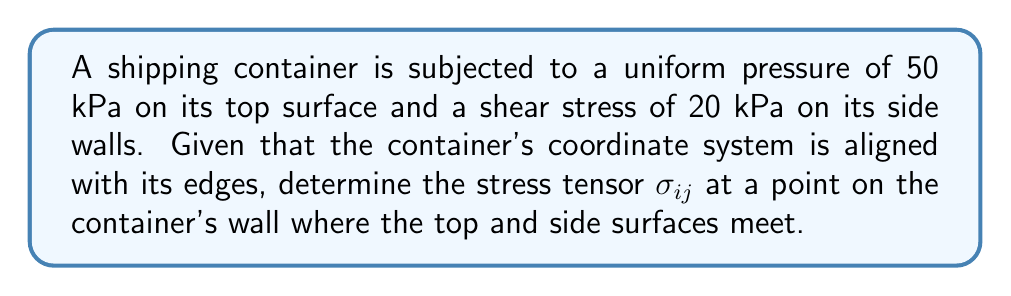Can you answer this question? To solve this problem, we'll follow these steps:

1) In tensor notation, the stress tensor $\sigma_{ij}$ is a 3x3 matrix representing the state of stress at a point. The components are:

   $$\sigma_{ij} = \begin{bmatrix} 
   \sigma_{xx} & \tau_{xy} & \tau_{xz} \\
   \tau_{yx} & \sigma_{yy} & \tau_{yz} \\
   \tau_{zx} & \tau_{zy} & \sigma_{zz}
   \end{bmatrix}$$

2) Given information:
   - Uniform pressure on top surface: 50 kPa
   - Shear stress on side walls: 20 kPa

3) Assume the coordinate system is as follows:
   - x-axis: along the length of the container
   - y-axis: along the width of the container
   - z-axis: along the height of the container

4) The uniform pressure on the top surface acts in the negative z-direction:
   $\sigma_{zz} = -50$ kPa

5) The shear stress on the side walls can be represented by $\tau_{xz}$ and $\tau_{yz}$:
   $\tau_{xz} = \tau_{zx} = 20$ kPa
   $\tau_{yz} = \tau_{zy} = 20$ kPa

6) All other components of the stress tensor are zero, as no other stresses are mentioned.

7) Therefore, the complete stress tensor is:

   $$\sigma_{ij} = \begin{bmatrix} 
   0 & 0 & 20 \\
   0 & 0 & 20 \\
   20 & 20 & -50
   \end{bmatrix}$$ kPa
Answer: $$\sigma_{ij} = \begin{bmatrix} 
0 & 0 & 20 \\
0 & 0 & 20 \\
20 & 20 & -50
\end{bmatrix}$$ kPa 